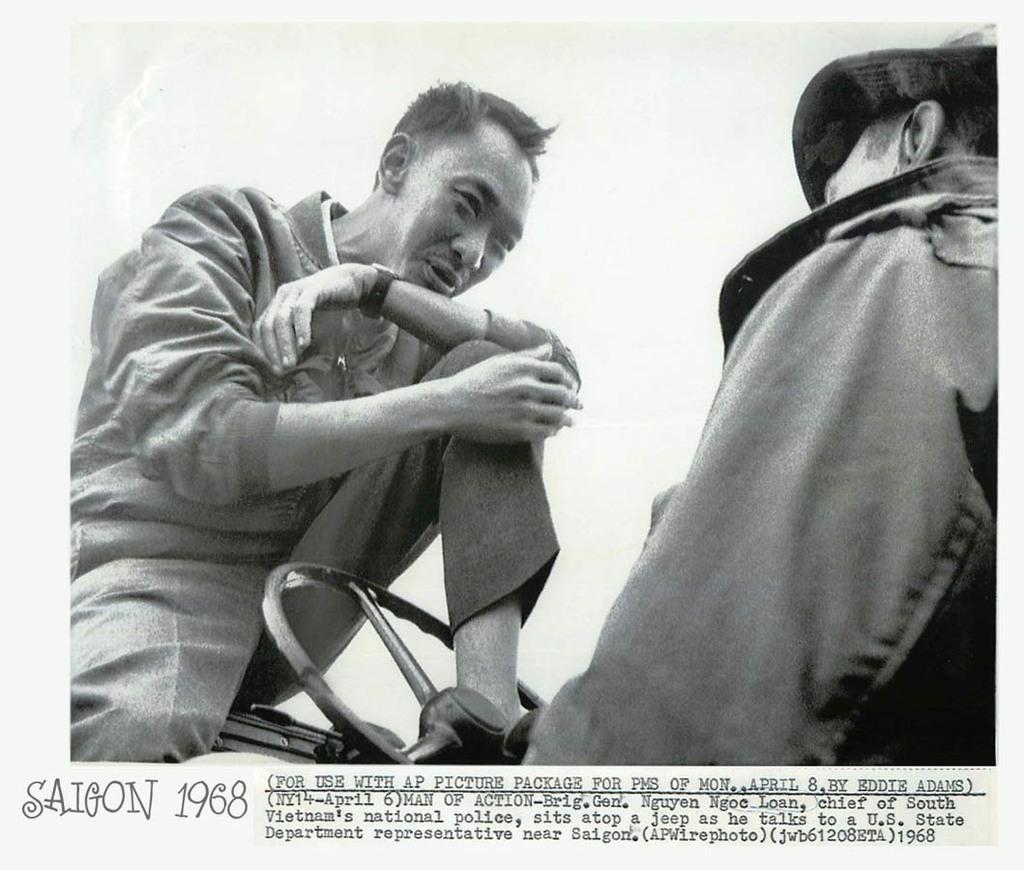Could you give a brief overview of what you see in this image? There is a man on the right side of the image and there is another man on the left side. There is steering and a text at the bottom side. 